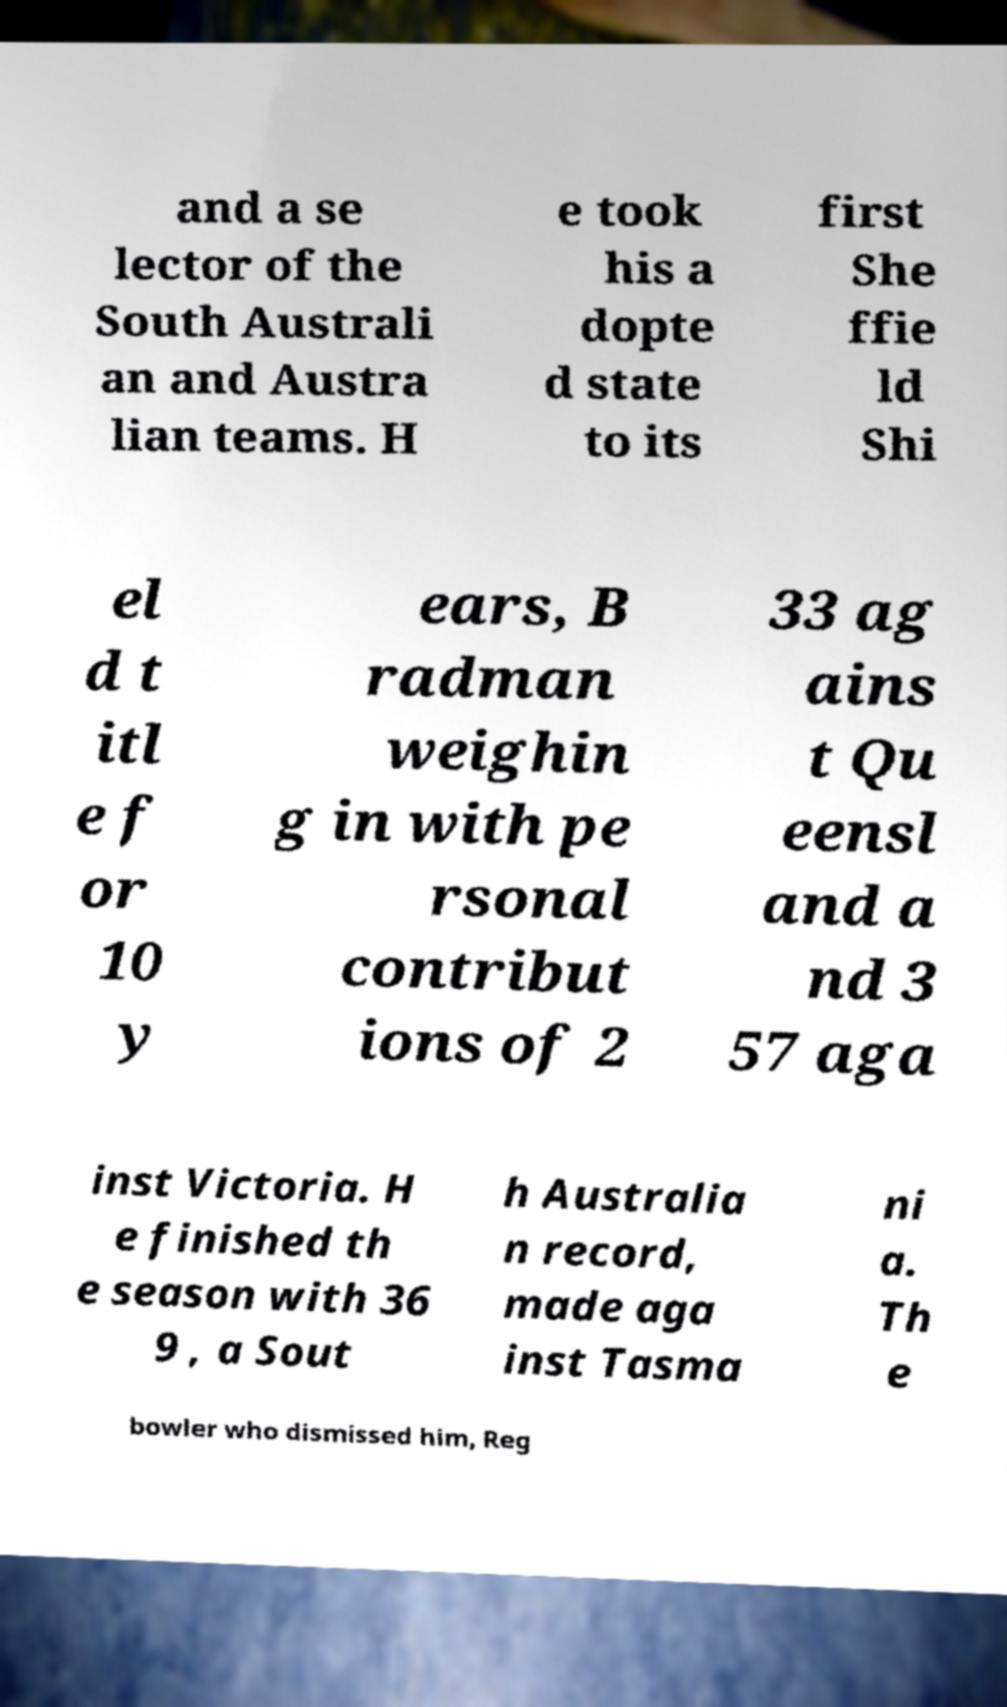Could you extract and type out the text from this image? and a se lector of the South Australi an and Austra lian teams. H e took his a dopte d state to its first She ffie ld Shi el d t itl e f or 10 y ears, B radman weighin g in with pe rsonal contribut ions of 2 33 ag ains t Qu eensl and a nd 3 57 aga inst Victoria. H e finished th e season with 36 9 , a Sout h Australia n record, made aga inst Tasma ni a. Th e bowler who dismissed him, Reg 